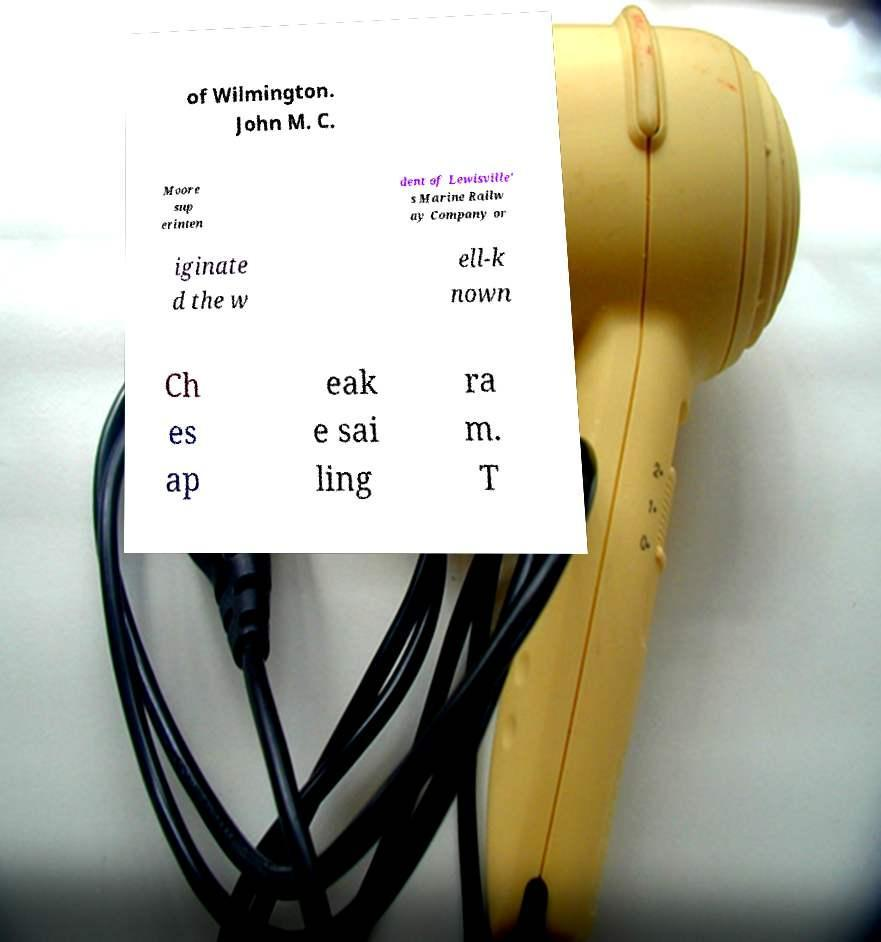Can you read and provide the text displayed in the image?This photo seems to have some interesting text. Can you extract and type it out for me? of Wilmington. John M. C. Moore sup erinten dent of Lewisville' s Marine Railw ay Company or iginate d the w ell-k nown Ch es ap eak e sai ling ra m. T 